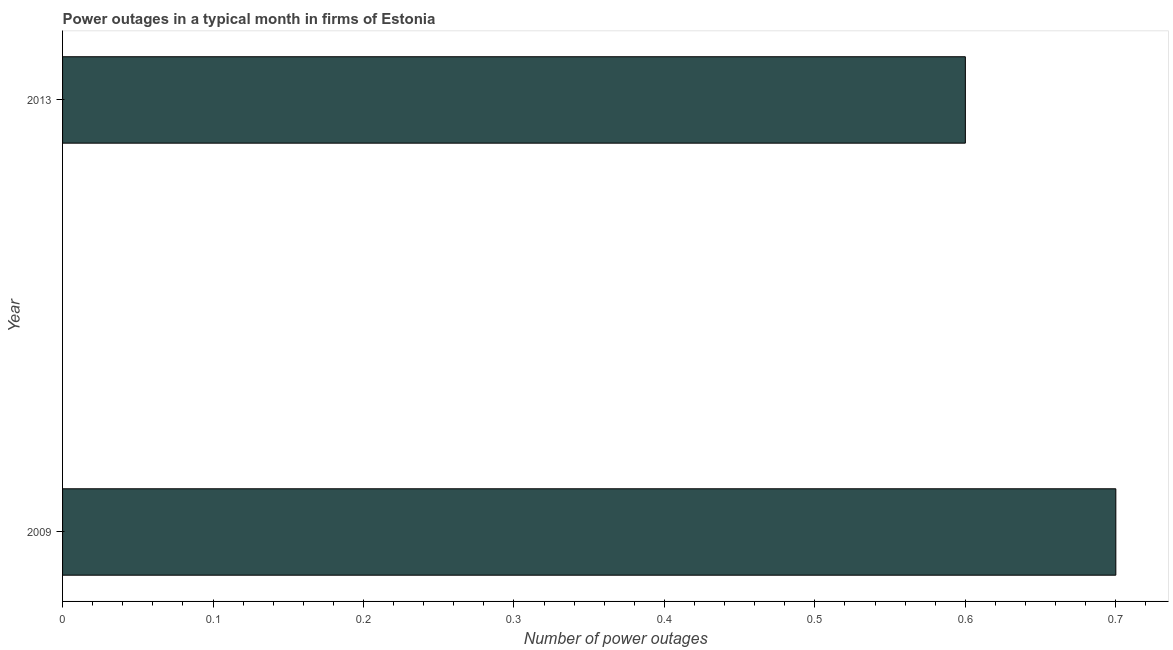Does the graph contain any zero values?
Offer a very short reply. No. Does the graph contain grids?
Provide a short and direct response. No. What is the title of the graph?
Your response must be concise. Power outages in a typical month in firms of Estonia. What is the label or title of the X-axis?
Your answer should be very brief. Number of power outages. Across all years, what is the maximum number of power outages?
Your answer should be very brief. 0.7. Across all years, what is the minimum number of power outages?
Your response must be concise. 0.6. In which year was the number of power outages maximum?
Ensure brevity in your answer.  2009. What is the sum of the number of power outages?
Your answer should be very brief. 1.3. What is the average number of power outages per year?
Your answer should be very brief. 0.65. What is the median number of power outages?
Make the answer very short. 0.65. Do a majority of the years between 2009 and 2013 (inclusive) have number of power outages greater than 0.14 ?
Give a very brief answer. Yes. What is the ratio of the number of power outages in 2009 to that in 2013?
Keep it short and to the point. 1.17. Is the number of power outages in 2009 less than that in 2013?
Give a very brief answer. No. In how many years, is the number of power outages greater than the average number of power outages taken over all years?
Provide a succinct answer. 1. How many years are there in the graph?
Offer a very short reply. 2. What is the difference between the Number of power outages in 2009 and 2013?
Keep it short and to the point. 0.1. What is the ratio of the Number of power outages in 2009 to that in 2013?
Your answer should be very brief. 1.17. 